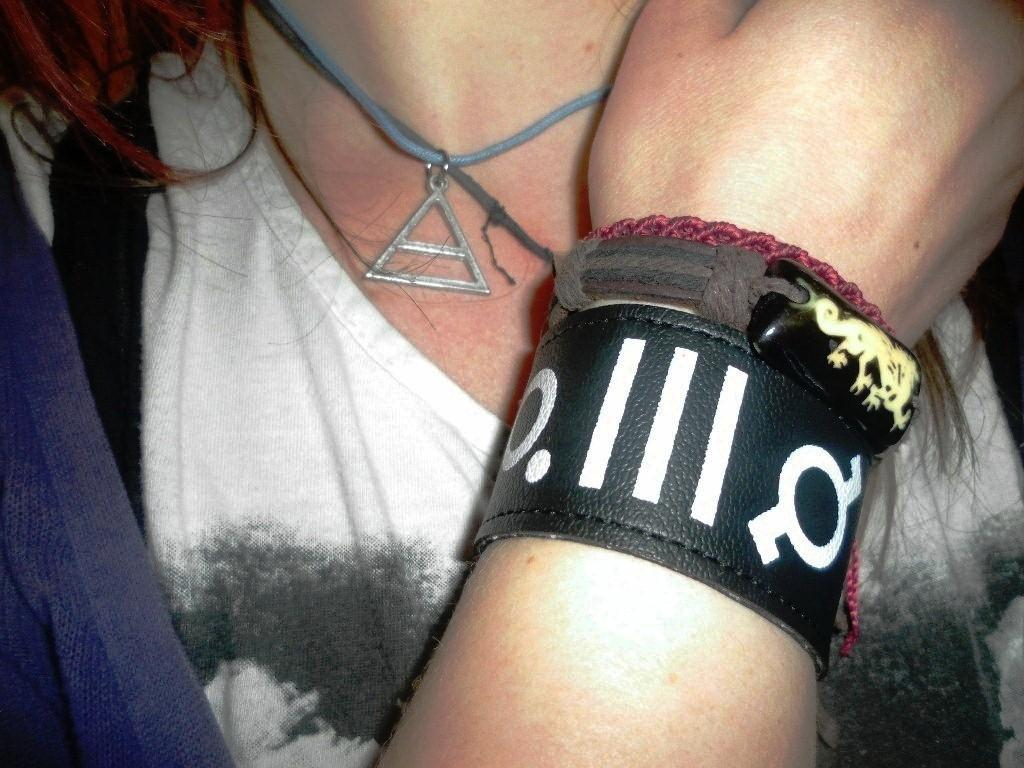What is the main subject of the image? The main subject of the image is a woman. What is the woman wearing on her hand? The woman is wearing a hand band. How many potatoes can be seen in the image? There are no potatoes present in the image. What type of class is being held in the image? There is no class depicted in the image. 